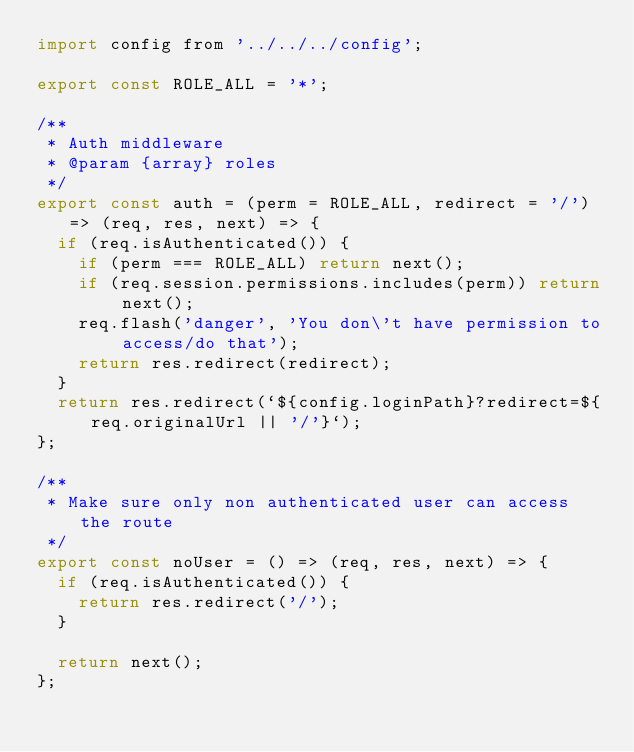<code> <loc_0><loc_0><loc_500><loc_500><_JavaScript_>import config from '../../../config';

export const ROLE_ALL = '*';

/**
 * Auth middleware
 * @param {array} roles
 */
export const auth = (perm = ROLE_ALL, redirect = '/') => (req, res, next) => {
  if (req.isAuthenticated()) {
    if (perm === ROLE_ALL) return next();
    if (req.session.permissions.includes(perm)) return next();
    req.flash('danger', 'You don\'t have permission to access/do that');
    return res.redirect(redirect);
  }
  return res.redirect(`${config.loginPath}?redirect=${req.originalUrl || '/'}`);
};

/**
 * Make sure only non authenticated user can access the route
 */
export const noUser = () => (req, res, next) => {
  if (req.isAuthenticated()) {
    return res.redirect('/');
  }

  return next();
};
</code> 